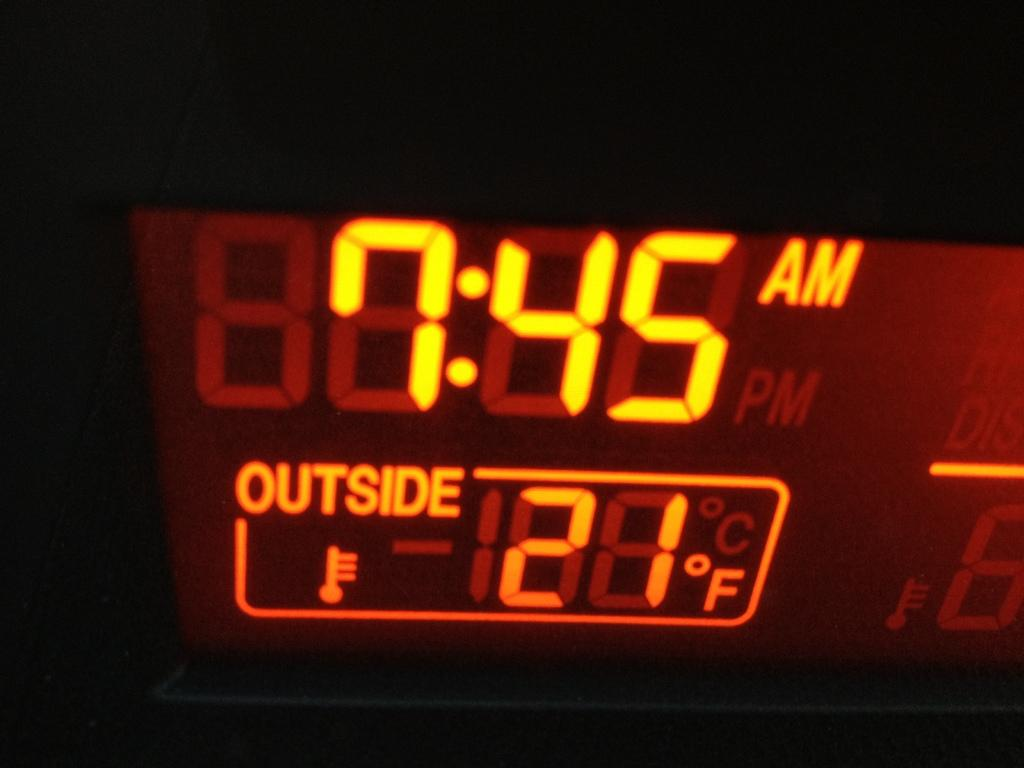<image>
Describe the image concisely. A close up of a device telling the time and the outside temperature. 